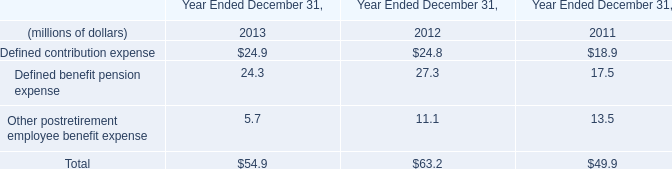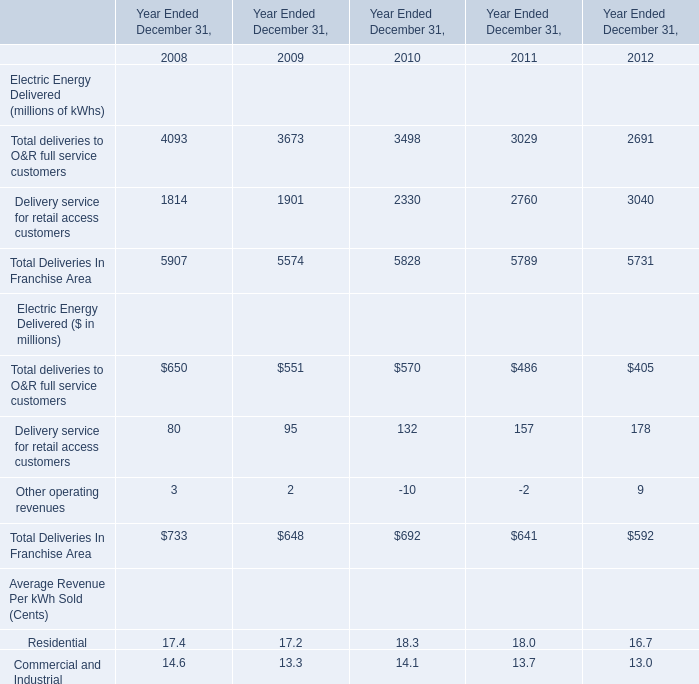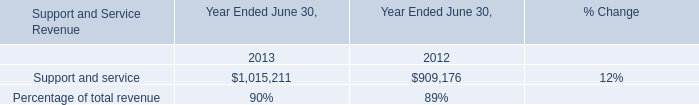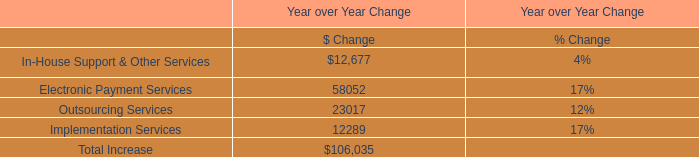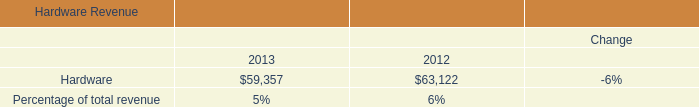What's the average of Support and service of Year Ended June 30, 2013, and Hardware of data 1 2012 ? 
Computations: ((1015211.0 + 63122.0) / 2)
Answer: 539166.5. 